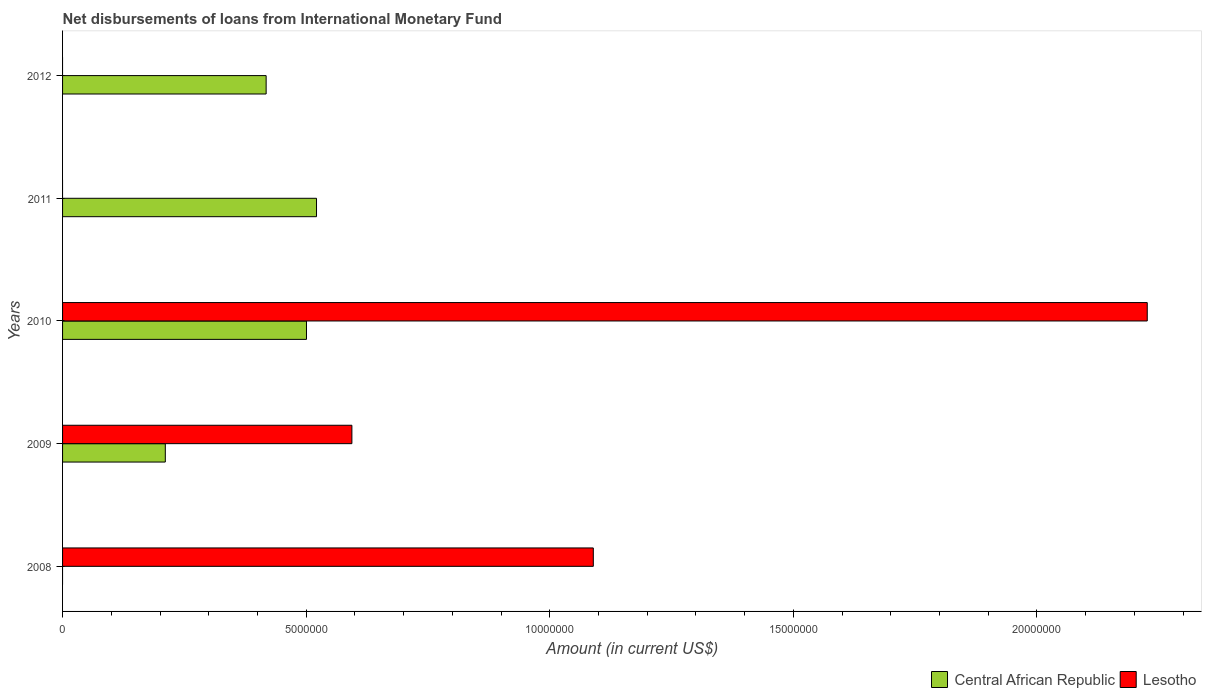How many different coloured bars are there?
Provide a short and direct response. 2. Are the number of bars per tick equal to the number of legend labels?
Your answer should be very brief. No. How many bars are there on the 5th tick from the top?
Your answer should be compact. 1. How many bars are there on the 3rd tick from the bottom?
Make the answer very short. 2. What is the amount of loans disbursed in Central African Republic in 2009?
Your response must be concise. 2.11e+06. Across all years, what is the maximum amount of loans disbursed in Central African Republic?
Give a very brief answer. 5.21e+06. Across all years, what is the minimum amount of loans disbursed in Lesotho?
Provide a short and direct response. 0. In which year was the amount of loans disbursed in Lesotho maximum?
Provide a short and direct response. 2010. What is the total amount of loans disbursed in Central African Republic in the graph?
Make the answer very short. 1.65e+07. What is the difference between the amount of loans disbursed in Central African Republic in 2009 and that in 2010?
Provide a succinct answer. -2.90e+06. What is the difference between the amount of loans disbursed in Lesotho in 2009 and the amount of loans disbursed in Central African Republic in 2011?
Keep it short and to the point. 7.26e+05. What is the average amount of loans disbursed in Lesotho per year?
Ensure brevity in your answer.  7.82e+06. In the year 2010, what is the difference between the amount of loans disbursed in Lesotho and amount of loans disbursed in Central African Republic?
Your response must be concise. 1.73e+07. In how many years, is the amount of loans disbursed in Central African Republic greater than 1000000 US$?
Ensure brevity in your answer.  4. What is the ratio of the amount of loans disbursed in Central African Republic in 2009 to that in 2012?
Offer a terse response. 0.5. Is the difference between the amount of loans disbursed in Lesotho in 2009 and 2010 greater than the difference between the amount of loans disbursed in Central African Republic in 2009 and 2010?
Offer a terse response. No. What is the difference between the highest and the second highest amount of loans disbursed in Lesotho?
Make the answer very short. 1.14e+07. What is the difference between the highest and the lowest amount of loans disbursed in Central African Republic?
Provide a succinct answer. 5.21e+06. In how many years, is the amount of loans disbursed in Central African Republic greater than the average amount of loans disbursed in Central African Republic taken over all years?
Offer a terse response. 3. Is the sum of the amount of loans disbursed in Central African Republic in 2009 and 2010 greater than the maximum amount of loans disbursed in Lesotho across all years?
Your answer should be compact. No. How many years are there in the graph?
Provide a succinct answer. 5. Are the values on the major ticks of X-axis written in scientific E-notation?
Offer a terse response. No. Does the graph contain any zero values?
Provide a succinct answer. Yes. Where does the legend appear in the graph?
Make the answer very short. Bottom right. How are the legend labels stacked?
Ensure brevity in your answer.  Horizontal. What is the title of the graph?
Make the answer very short. Net disbursements of loans from International Monetary Fund. What is the label or title of the X-axis?
Offer a terse response. Amount (in current US$). What is the label or title of the Y-axis?
Give a very brief answer. Years. What is the Amount (in current US$) of Central African Republic in 2008?
Your answer should be very brief. 0. What is the Amount (in current US$) in Lesotho in 2008?
Keep it short and to the point. 1.09e+07. What is the Amount (in current US$) in Central African Republic in 2009?
Ensure brevity in your answer.  2.11e+06. What is the Amount (in current US$) in Lesotho in 2009?
Offer a very short reply. 5.94e+06. What is the Amount (in current US$) in Central African Republic in 2010?
Your answer should be compact. 5.01e+06. What is the Amount (in current US$) in Lesotho in 2010?
Give a very brief answer. 2.23e+07. What is the Amount (in current US$) in Central African Republic in 2011?
Offer a very short reply. 5.21e+06. What is the Amount (in current US$) in Lesotho in 2011?
Make the answer very short. 0. What is the Amount (in current US$) of Central African Republic in 2012?
Your answer should be compact. 4.18e+06. What is the Amount (in current US$) of Lesotho in 2012?
Keep it short and to the point. 0. Across all years, what is the maximum Amount (in current US$) of Central African Republic?
Make the answer very short. 5.21e+06. Across all years, what is the maximum Amount (in current US$) of Lesotho?
Provide a succinct answer. 2.23e+07. Across all years, what is the minimum Amount (in current US$) in Central African Republic?
Keep it short and to the point. 0. Across all years, what is the minimum Amount (in current US$) in Lesotho?
Give a very brief answer. 0. What is the total Amount (in current US$) in Central African Republic in the graph?
Give a very brief answer. 1.65e+07. What is the total Amount (in current US$) of Lesotho in the graph?
Give a very brief answer. 3.91e+07. What is the difference between the Amount (in current US$) in Lesotho in 2008 and that in 2009?
Provide a short and direct response. 4.96e+06. What is the difference between the Amount (in current US$) of Lesotho in 2008 and that in 2010?
Keep it short and to the point. -1.14e+07. What is the difference between the Amount (in current US$) of Central African Republic in 2009 and that in 2010?
Give a very brief answer. -2.90e+06. What is the difference between the Amount (in current US$) in Lesotho in 2009 and that in 2010?
Your response must be concise. -1.63e+07. What is the difference between the Amount (in current US$) in Central African Republic in 2009 and that in 2011?
Provide a succinct answer. -3.10e+06. What is the difference between the Amount (in current US$) of Central African Republic in 2009 and that in 2012?
Offer a terse response. -2.07e+06. What is the difference between the Amount (in current US$) of Central African Republic in 2010 and that in 2011?
Provide a succinct answer. -2.06e+05. What is the difference between the Amount (in current US$) in Central African Republic in 2010 and that in 2012?
Make the answer very short. 8.28e+05. What is the difference between the Amount (in current US$) of Central African Republic in 2011 and that in 2012?
Your response must be concise. 1.03e+06. What is the difference between the Amount (in current US$) of Central African Republic in 2009 and the Amount (in current US$) of Lesotho in 2010?
Give a very brief answer. -2.02e+07. What is the average Amount (in current US$) of Central African Republic per year?
Ensure brevity in your answer.  3.30e+06. What is the average Amount (in current US$) in Lesotho per year?
Offer a very short reply. 7.82e+06. In the year 2009, what is the difference between the Amount (in current US$) in Central African Republic and Amount (in current US$) in Lesotho?
Provide a short and direct response. -3.83e+06. In the year 2010, what is the difference between the Amount (in current US$) of Central African Republic and Amount (in current US$) of Lesotho?
Offer a terse response. -1.73e+07. What is the ratio of the Amount (in current US$) in Lesotho in 2008 to that in 2009?
Your answer should be compact. 1.83. What is the ratio of the Amount (in current US$) in Lesotho in 2008 to that in 2010?
Provide a succinct answer. 0.49. What is the ratio of the Amount (in current US$) of Central African Republic in 2009 to that in 2010?
Make the answer very short. 0.42. What is the ratio of the Amount (in current US$) of Lesotho in 2009 to that in 2010?
Your answer should be very brief. 0.27. What is the ratio of the Amount (in current US$) of Central African Republic in 2009 to that in 2011?
Ensure brevity in your answer.  0.4. What is the ratio of the Amount (in current US$) in Central African Republic in 2009 to that in 2012?
Give a very brief answer. 0.5. What is the ratio of the Amount (in current US$) in Central African Republic in 2010 to that in 2011?
Keep it short and to the point. 0.96. What is the ratio of the Amount (in current US$) of Central African Republic in 2010 to that in 2012?
Provide a succinct answer. 1.2. What is the ratio of the Amount (in current US$) in Central African Republic in 2011 to that in 2012?
Provide a succinct answer. 1.25. What is the difference between the highest and the second highest Amount (in current US$) in Central African Republic?
Your answer should be very brief. 2.06e+05. What is the difference between the highest and the second highest Amount (in current US$) of Lesotho?
Give a very brief answer. 1.14e+07. What is the difference between the highest and the lowest Amount (in current US$) of Central African Republic?
Provide a succinct answer. 5.21e+06. What is the difference between the highest and the lowest Amount (in current US$) of Lesotho?
Provide a succinct answer. 2.23e+07. 